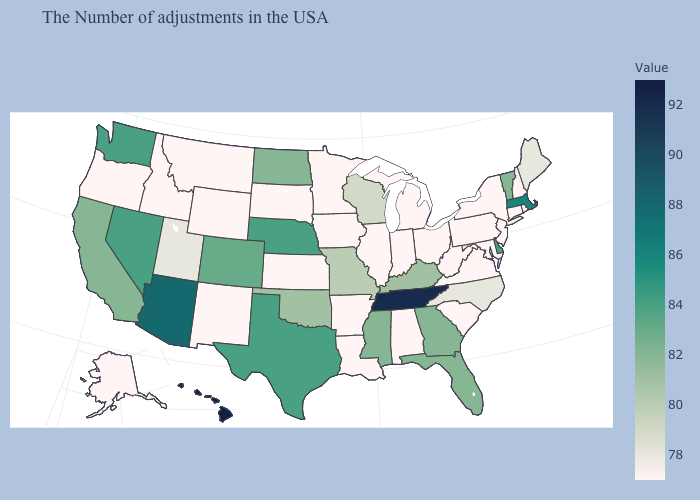Among the states that border Utah , does Arizona have the highest value?
Write a very short answer. Yes. Among the states that border Pennsylvania , does Delaware have the lowest value?
Answer briefly. No. Does Colorado have the highest value in the West?
Give a very brief answer. No. Does Alabama have the lowest value in the USA?
Keep it brief. Yes. Which states have the highest value in the USA?
Answer briefly. Hawaii. 